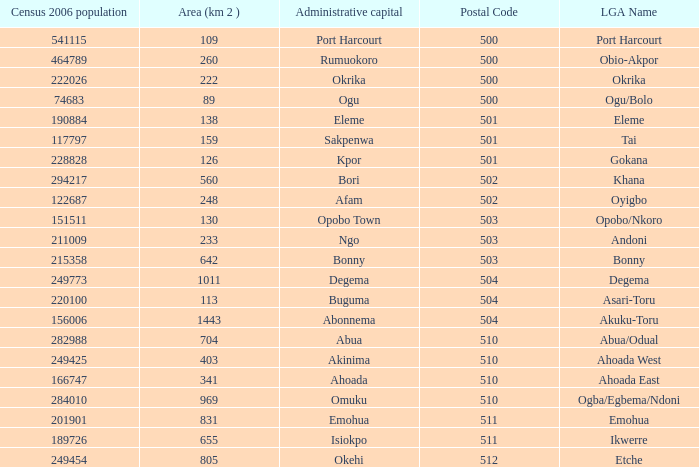What is the postal code when the administrative capital in Bori? 502.0. Would you mind parsing the complete table? {'header': ['Census 2006 population', 'Area (km 2 )', 'Administrative capital', 'Postal Code', 'LGA Name'], 'rows': [['541115', '109', 'Port Harcourt', '500', 'Port Harcourt'], ['464789', '260', 'Rumuokoro', '500', 'Obio-Akpor'], ['222026', '222', 'Okrika', '500', 'Okrika'], ['74683', '89', 'Ogu', '500', 'Ogu/Bolo'], ['190884', '138', 'Eleme', '501', 'Eleme'], ['117797', '159', 'Sakpenwa', '501', 'Tai'], ['228828', '126', 'Kpor', '501', 'Gokana'], ['294217', '560', 'Bori', '502', 'Khana'], ['122687', '248', 'Afam', '502', 'Oyigbo'], ['151511', '130', 'Opobo Town', '503', 'Opobo/Nkoro'], ['211009', '233', 'Ngo', '503', 'Andoni'], ['215358', '642', 'Bonny', '503', 'Bonny'], ['249773', '1011', 'Degema', '504', 'Degema'], ['220100', '113', 'Buguma', '504', 'Asari-Toru'], ['156006', '1443', 'Abonnema', '504', 'Akuku-Toru'], ['282988', '704', 'Abua', '510', 'Abua/Odual'], ['249425', '403', 'Akinima', '510', 'Ahoada West'], ['166747', '341', 'Ahoada', '510', 'Ahoada East'], ['284010', '969', 'Omuku', '510', 'Ogba/Egbema/Ndoni'], ['201901', '831', 'Emohua', '511', 'Emohua'], ['189726', '655', 'Isiokpo', '511', 'Ikwerre'], ['249454', '805', 'Okehi', '512', 'Etche']]} 